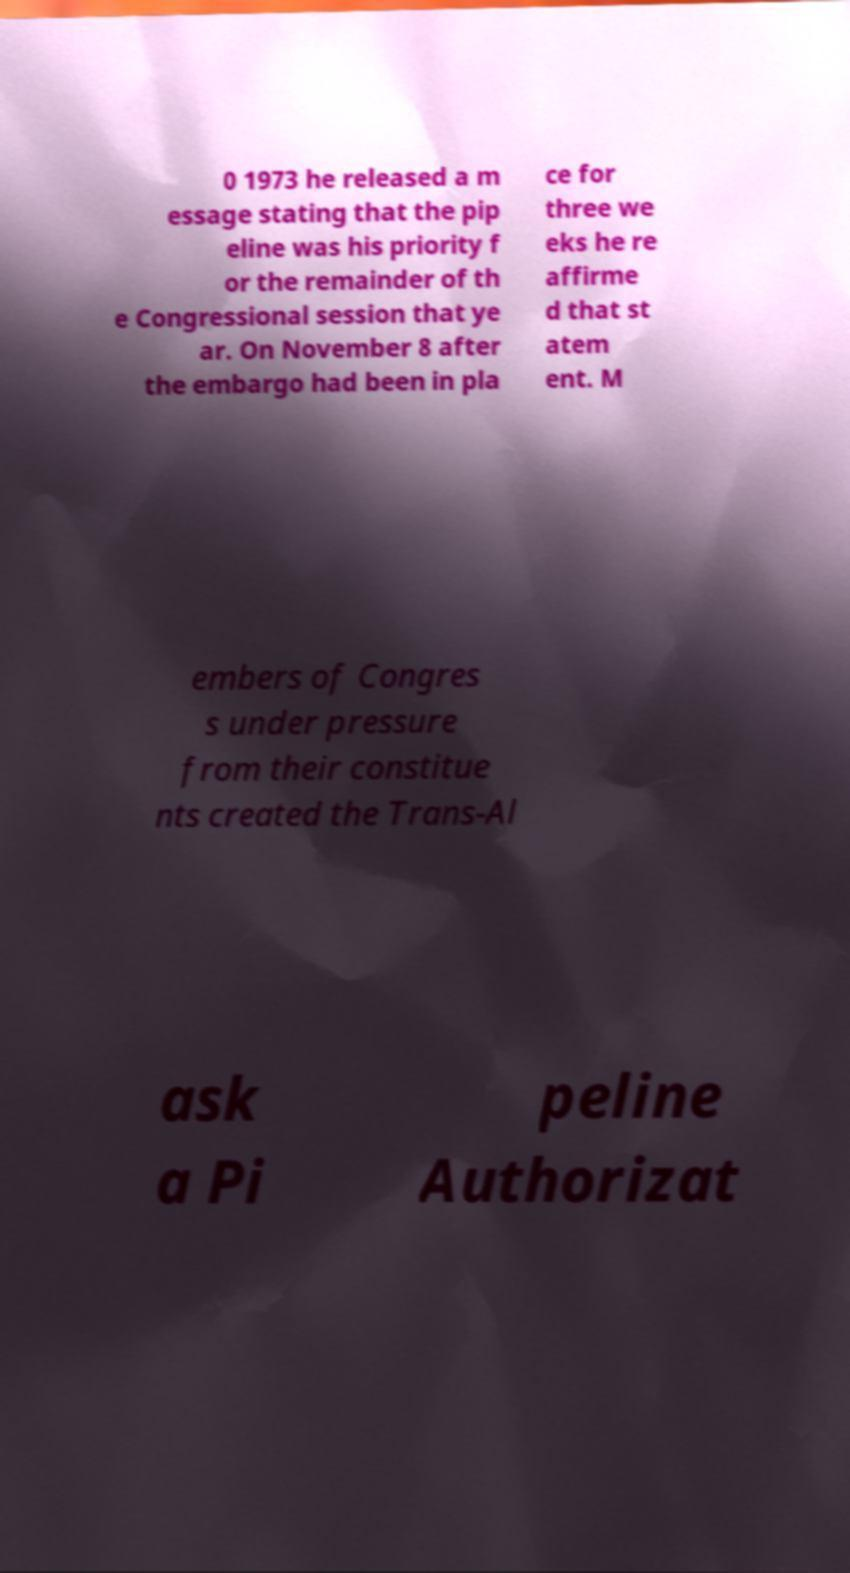Please identify and transcribe the text found in this image. 0 1973 he released a m essage stating that the pip eline was his priority f or the remainder of th e Congressional session that ye ar. On November 8 after the embargo had been in pla ce for three we eks he re affirme d that st atem ent. M embers of Congres s under pressure from their constitue nts created the Trans-Al ask a Pi peline Authorizat 